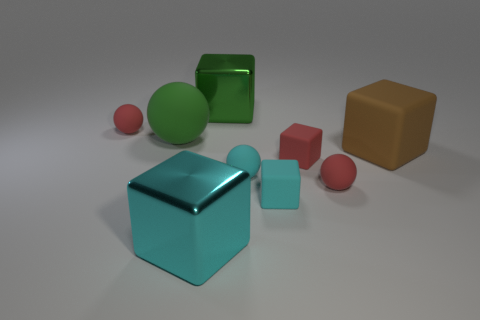There is another big shiny object that is the same shape as the green shiny object; what is its color?
Keep it short and to the point. Cyan. How many matte objects have the same color as the large ball?
Your response must be concise. 0. Are there more small cyan cubes that are behind the tiny cyan sphere than big cyan matte cubes?
Offer a very short reply. No. The large metal object in front of the red matte thing that is to the right of the tiny red cube is what color?
Your response must be concise. Cyan. How many things are metallic things left of the big green cube or large objects that are in front of the tiny cyan cube?
Your response must be concise. 1. The large ball has what color?
Your answer should be compact. Green. What number of big green balls have the same material as the red block?
Give a very brief answer. 1. Is the number of tiny red rubber objects greater than the number of brown matte blocks?
Ensure brevity in your answer.  Yes. What number of tiny matte cubes are behind the small red ball that is in front of the brown rubber thing?
Make the answer very short. 1. What number of objects are either spheres on the left side of the big cyan metal cube or big green objects?
Your answer should be very brief. 3. 